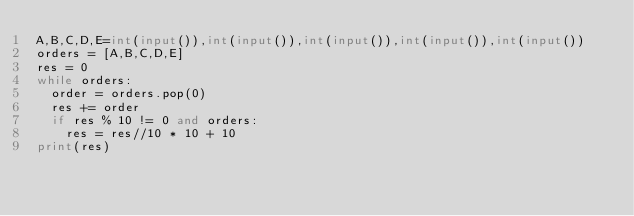<code> <loc_0><loc_0><loc_500><loc_500><_Python_>A,B,C,D,E=int(input()),int(input()),int(input()),int(input()),int(input())
orders = [A,B,C,D,E]
res = 0
while orders:
  order = orders.pop(0)
  res += order
  if res % 10 != 0 and orders:
    res = res//10 * 10 + 10
print(res)
</code> 